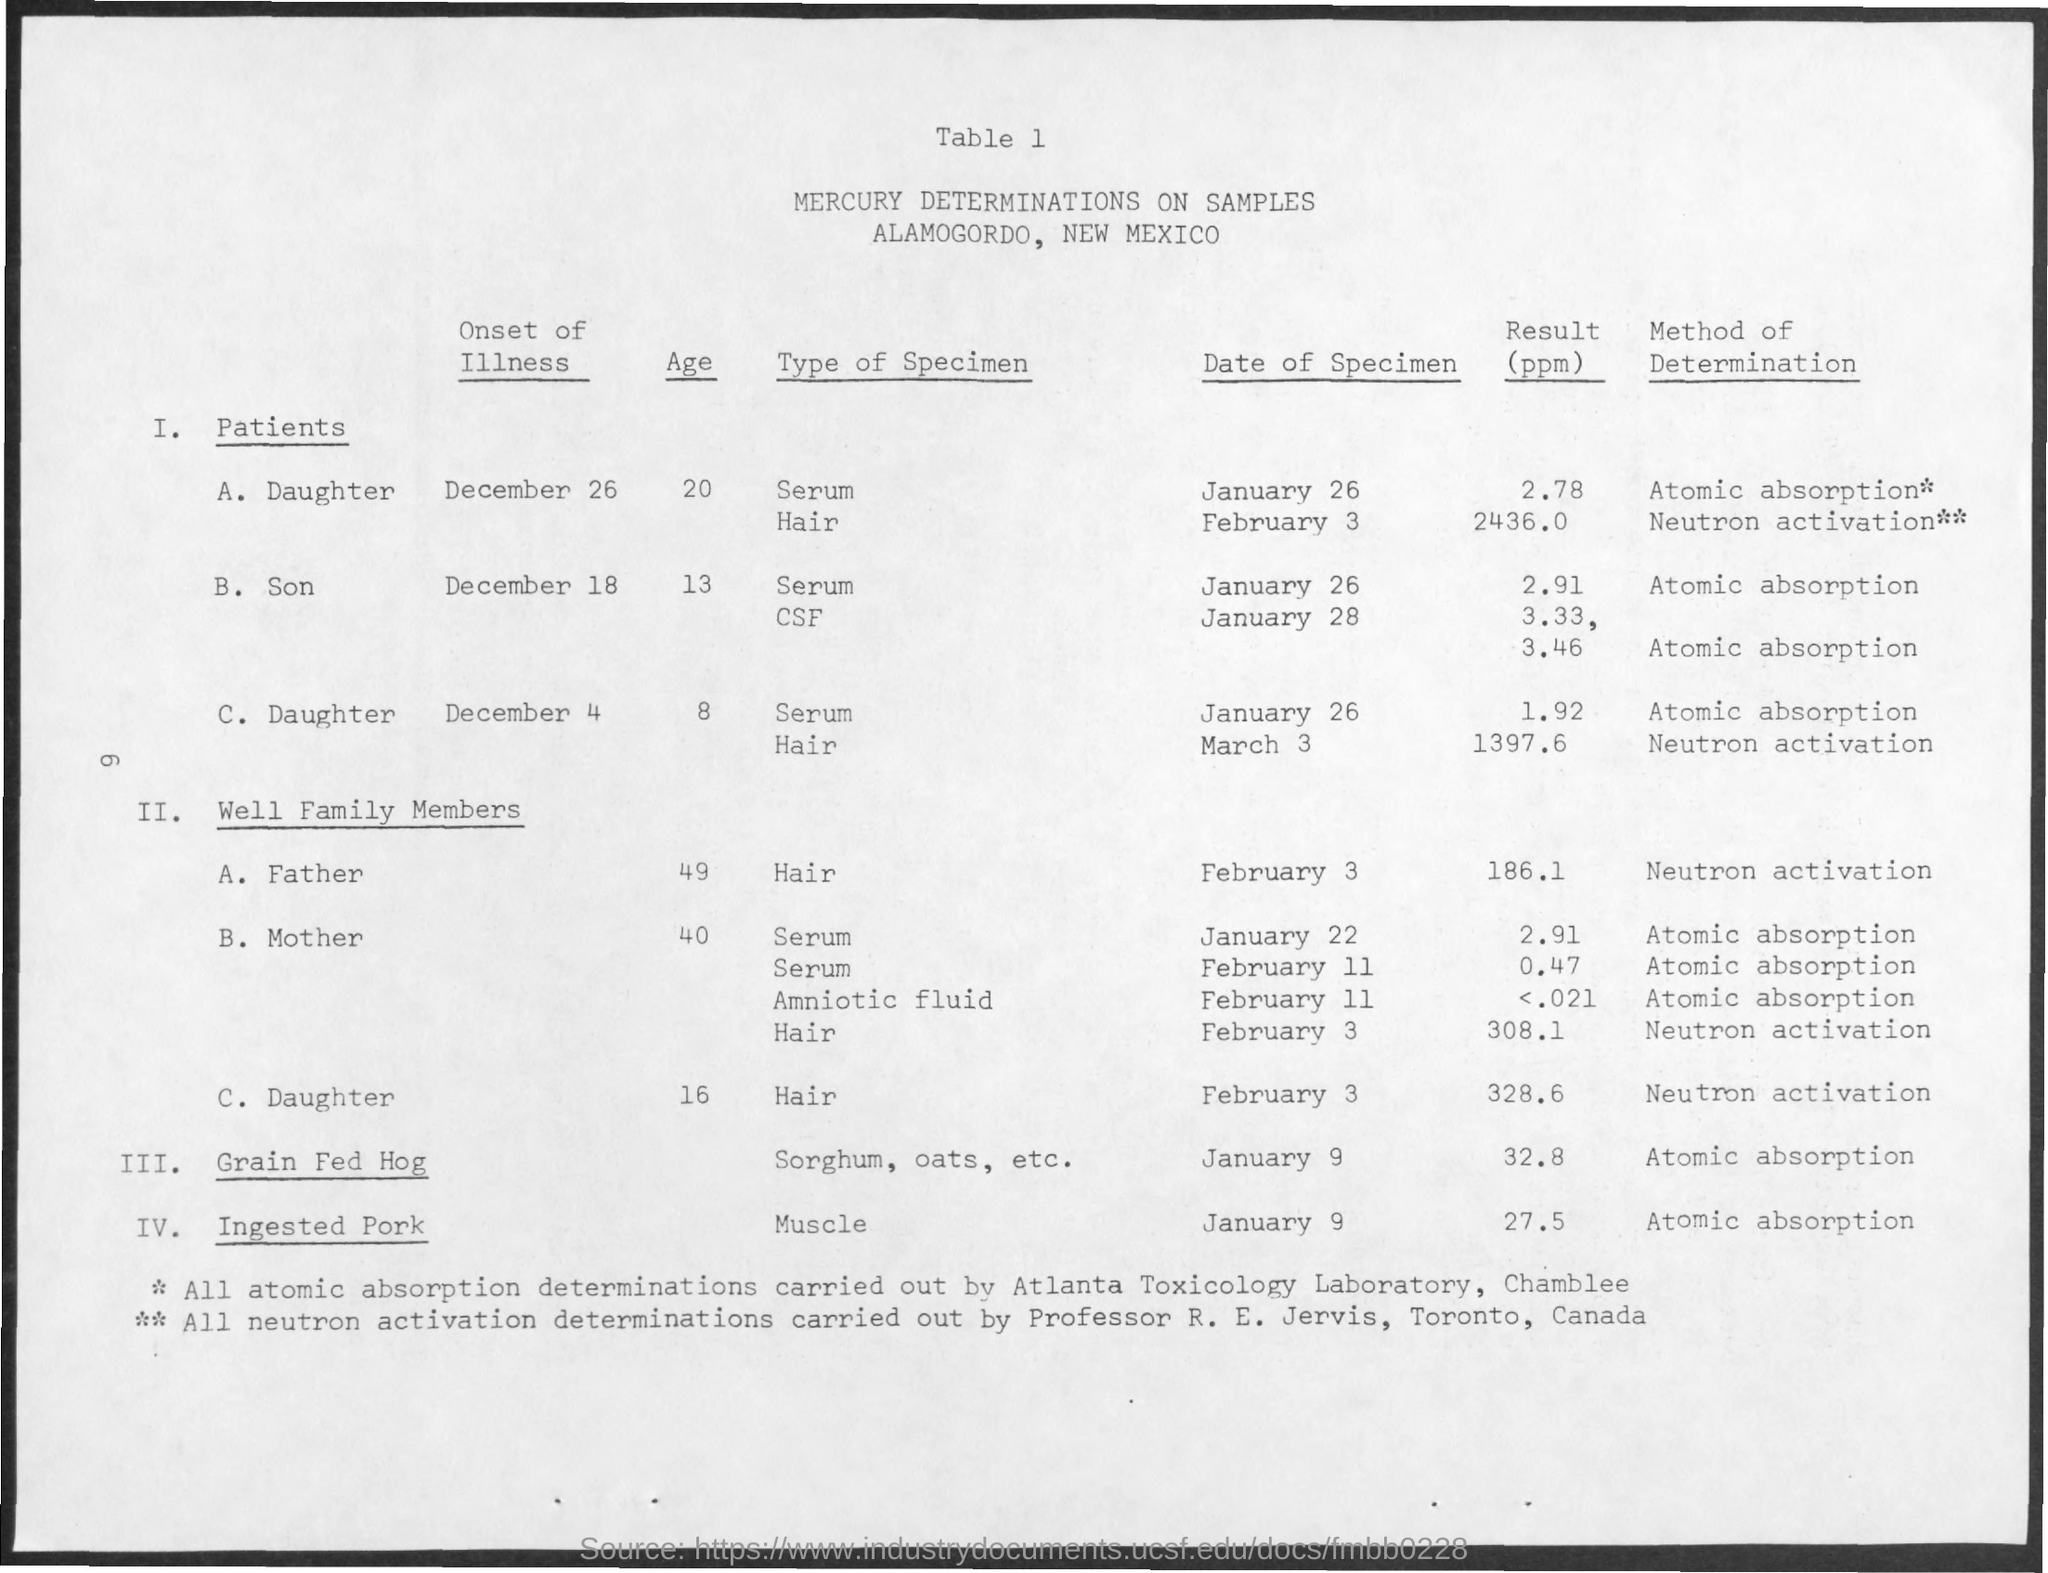Outline some significant characteristics in this image. The table heading is "Mercury determinations on samples. The method of determination for grain-fed hogs is atomic absorption. The date of the specimen for a grain-fed hog was January 9. All neutron activation determinations are performed by Professor R. E. Jervis. Atlanta Toxicology Laboratory in Chamblee is responsible for conducting all atomic absorption determinations. 